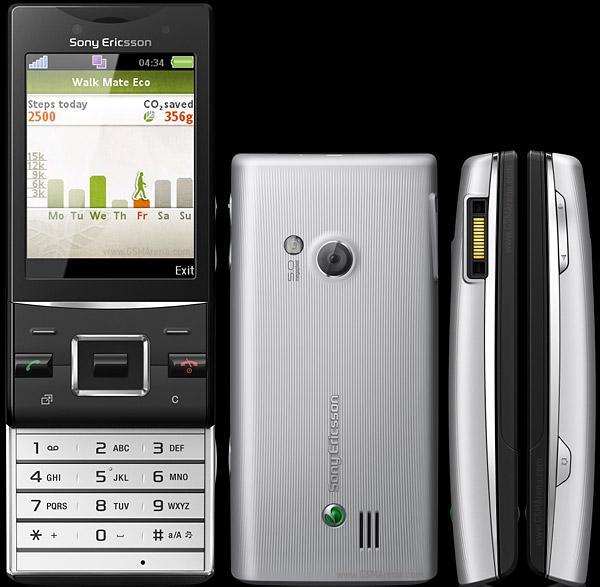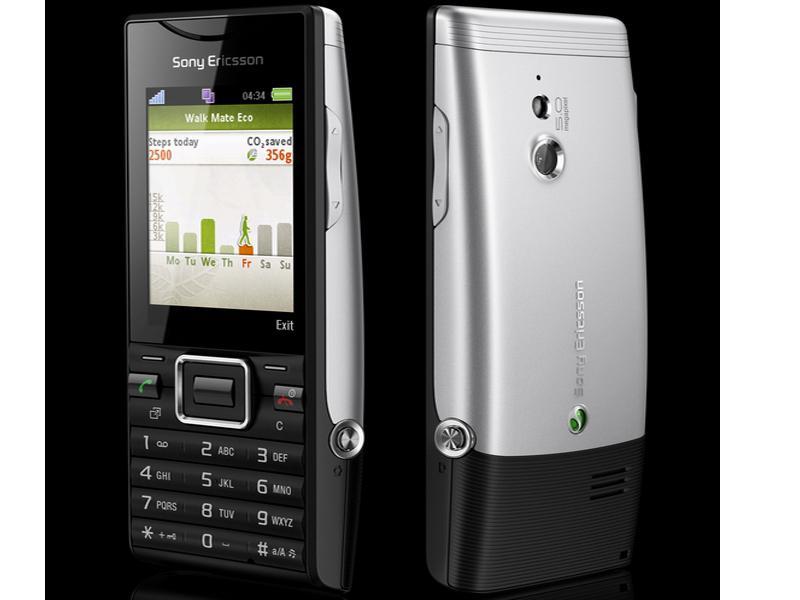The first image is the image on the left, the second image is the image on the right. For the images shown, is this caption "The left and right image contains the same number of phones." true? Answer yes or no. No. 